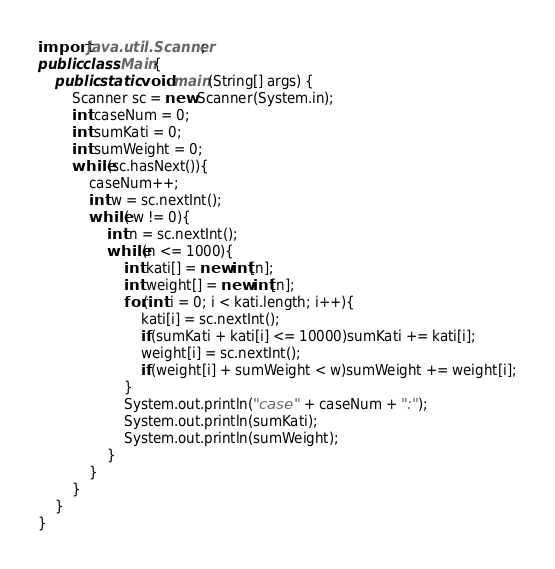<code> <loc_0><loc_0><loc_500><loc_500><_Java_>import java.util.Scanner;
public class Main{
	public static void main(String[] args) {
		Scanner sc = new Scanner(System.in);
		int caseNum = 0;
		int sumKati = 0;
		int sumWeight = 0;
		while(sc.hasNext()){
			caseNum++;
			int w = sc.nextInt();
			while( w != 0){
				int n = sc.nextInt();
				while(n <= 1000){
					int kati[] = new int[n];
					int weight[] = new int[n];
					for(int i = 0; i < kati.length; i++){
						kati[i] = sc.nextInt();
						if(sumKati + kati[i] <= 10000)sumKati += kati[i];
						weight[i] = sc.nextInt();
						if(weight[i] + sumWeight < w)sumWeight += weight[i];
					}
					System.out.println("case " + caseNum + ":");
					System.out.println(sumKati);
					System.out.println(sumWeight);
				}
			}
		}
	}
}</code> 